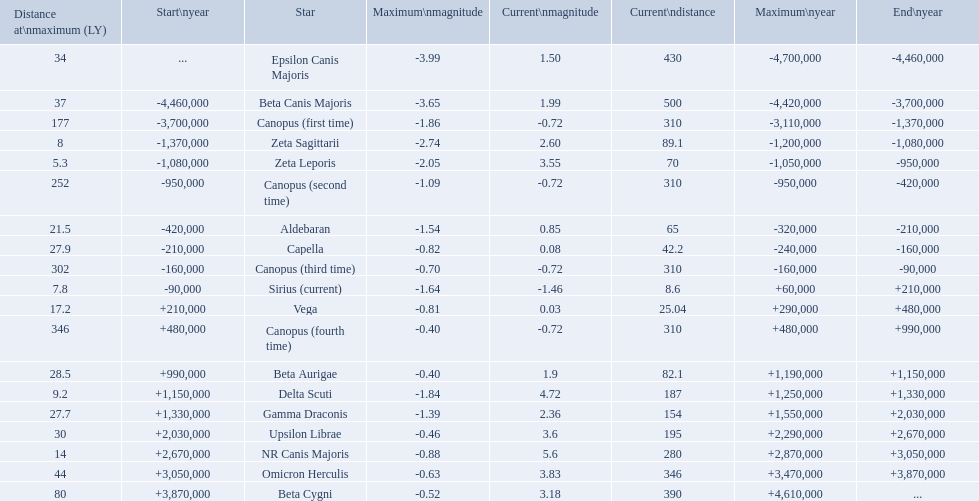What are all the stars? Epsilon Canis Majoris, Beta Canis Majoris, Canopus (first time), Zeta Sagittarii, Zeta Leporis, Canopus (second time), Aldebaran, Capella, Canopus (third time), Sirius (current), Vega, Canopus (fourth time), Beta Aurigae, Delta Scuti, Gamma Draconis, Upsilon Librae, NR Canis Majoris, Omicron Herculis, Beta Cygni. Of those, which star has a maximum distance of 80? Beta Cygni. I'm looking to parse the entire table for insights. Could you assist me with that? {'header': ['Distance at\\nmaximum (LY)', 'Start\\nyear', 'Star', 'Maximum\\nmagnitude', 'Current\\nmagnitude', 'Current\\ndistance', 'Maximum\\nyear', 'End\\nyear'], 'rows': [['34', '...', 'Epsilon Canis Majoris', '-3.99', '1.50', '430', '-4,700,000', '-4,460,000'], ['37', '-4,460,000', 'Beta Canis Majoris', '-3.65', '1.99', '500', '-4,420,000', '-3,700,000'], ['177', '-3,700,000', 'Canopus (first time)', '-1.86', '-0.72', '310', '-3,110,000', '-1,370,000'], ['8', '-1,370,000', 'Zeta Sagittarii', '-2.74', '2.60', '89.1', '-1,200,000', '-1,080,000'], ['5.3', '-1,080,000', 'Zeta Leporis', '-2.05', '3.55', '70', '-1,050,000', '-950,000'], ['252', '-950,000', 'Canopus (second time)', '-1.09', '-0.72', '310', '-950,000', '-420,000'], ['21.5', '-420,000', 'Aldebaran', '-1.54', '0.85', '65', '-320,000', '-210,000'], ['27.9', '-210,000', 'Capella', '-0.82', '0.08', '42.2', '-240,000', '-160,000'], ['302', '-160,000', 'Canopus (third time)', '-0.70', '-0.72', '310', '-160,000', '-90,000'], ['7.8', '-90,000', 'Sirius (current)', '-1.64', '-1.46', '8.6', '+60,000', '+210,000'], ['17.2', '+210,000', 'Vega', '-0.81', '0.03', '25.04', '+290,000', '+480,000'], ['346', '+480,000', 'Canopus (fourth time)', '-0.40', '-0.72', '310', '+480,000', '+990,000'], ['28.5', '+990,000', 'Beta Aurigae', '-0.40', '1.9', '82.1', '+1,190,000', '+1,150,000'], ['9.2', '+1,150,000', 'Delta Scuti', '-1.84', '4.72', '187', '+1,250,000', '+1,330,000'], ['27.7', '+1,330,000', 'Gamma Draconis', '-1.39', '2.36', '154', '+1,550,000', '+2,030,000'], ['30', '+2,030,000', 'Upsilon Librae', '-0.46', '3.6', '195', '+2,290,000', '+2,670,000'], ['14', '+2,670,000', 'NR Canis Majoris', '-0.88', '5.6', '280', '+2,870,000', '+3,050,000'], ['44', '+3,050,000', 'Omicron Herculis', '-0.63', '3.83', '346', '+3,470,000', '+3,870,000'], ['80', '+3,870,000', 'Beta Cygni', '-0.52', '3.18', '390', '+4,610,000', '...']]} 